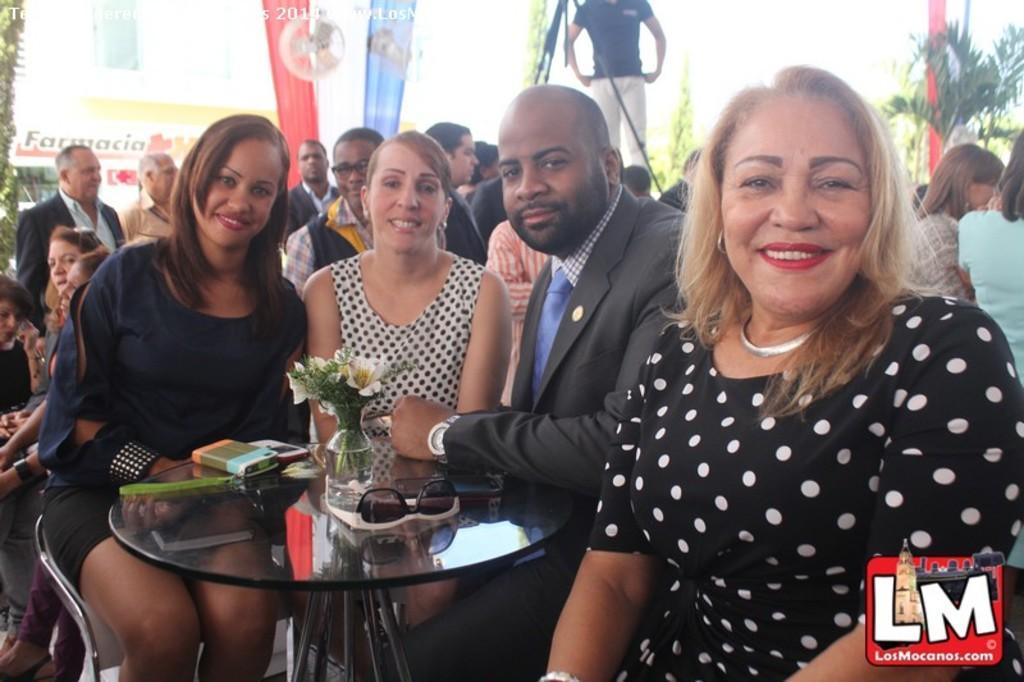In one or two sentences, can you explain what this image depicts? In the image few people are sitting and standing. Behind them there are some banners and plants and trees. Bottom left side of the image there is a table, on the table there are some glass and mobile phones and flower vase and flowers. 